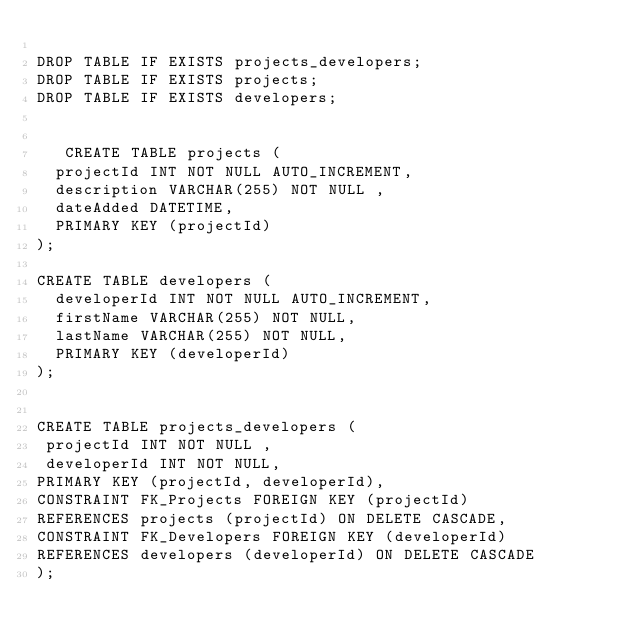Convert code to text. <code><loc_0><loc_0><loc_500><loc_500><_SQL_>
DROP TABLE IF EXISTS projects_developers;
DROP TABLE IF EXISTS projects;
DROP TABLE IF EXISTS developers;


   CREATE TABLE projects (
  projectId INT NOT NULL AUTO_INCREMENT,
  description VARCHAR(255) NOT NULL ,
  dateAdded DATETIME,
  PRIMARY KEY (projectId)
);

CREATE TABLE developers (
  developerId INT NOT NULL AUTO_INCREMENT,
  firstName VARCHAR(255) NOT NULL,
  lastName VARCHAR(255) NOT NULL,
  PRIMARY KEY (developerId)
);


CREATE TABLE projects_developers (
 projectId INT NOT NULL ,
 developerId INT NOT NULL,
PRIMARY KEY (projectId, developerId),
CONSTRAINT FK_Projects FOREIGN KEY (projectId)
REFERENCES projects (projectId) ON DELETE CASCADE,
CONSTRAINT FK_Developers FOREIGN KEY (developerId)
REFERENCES developers (developerId) ON DELETE CASCADE
);</code> 